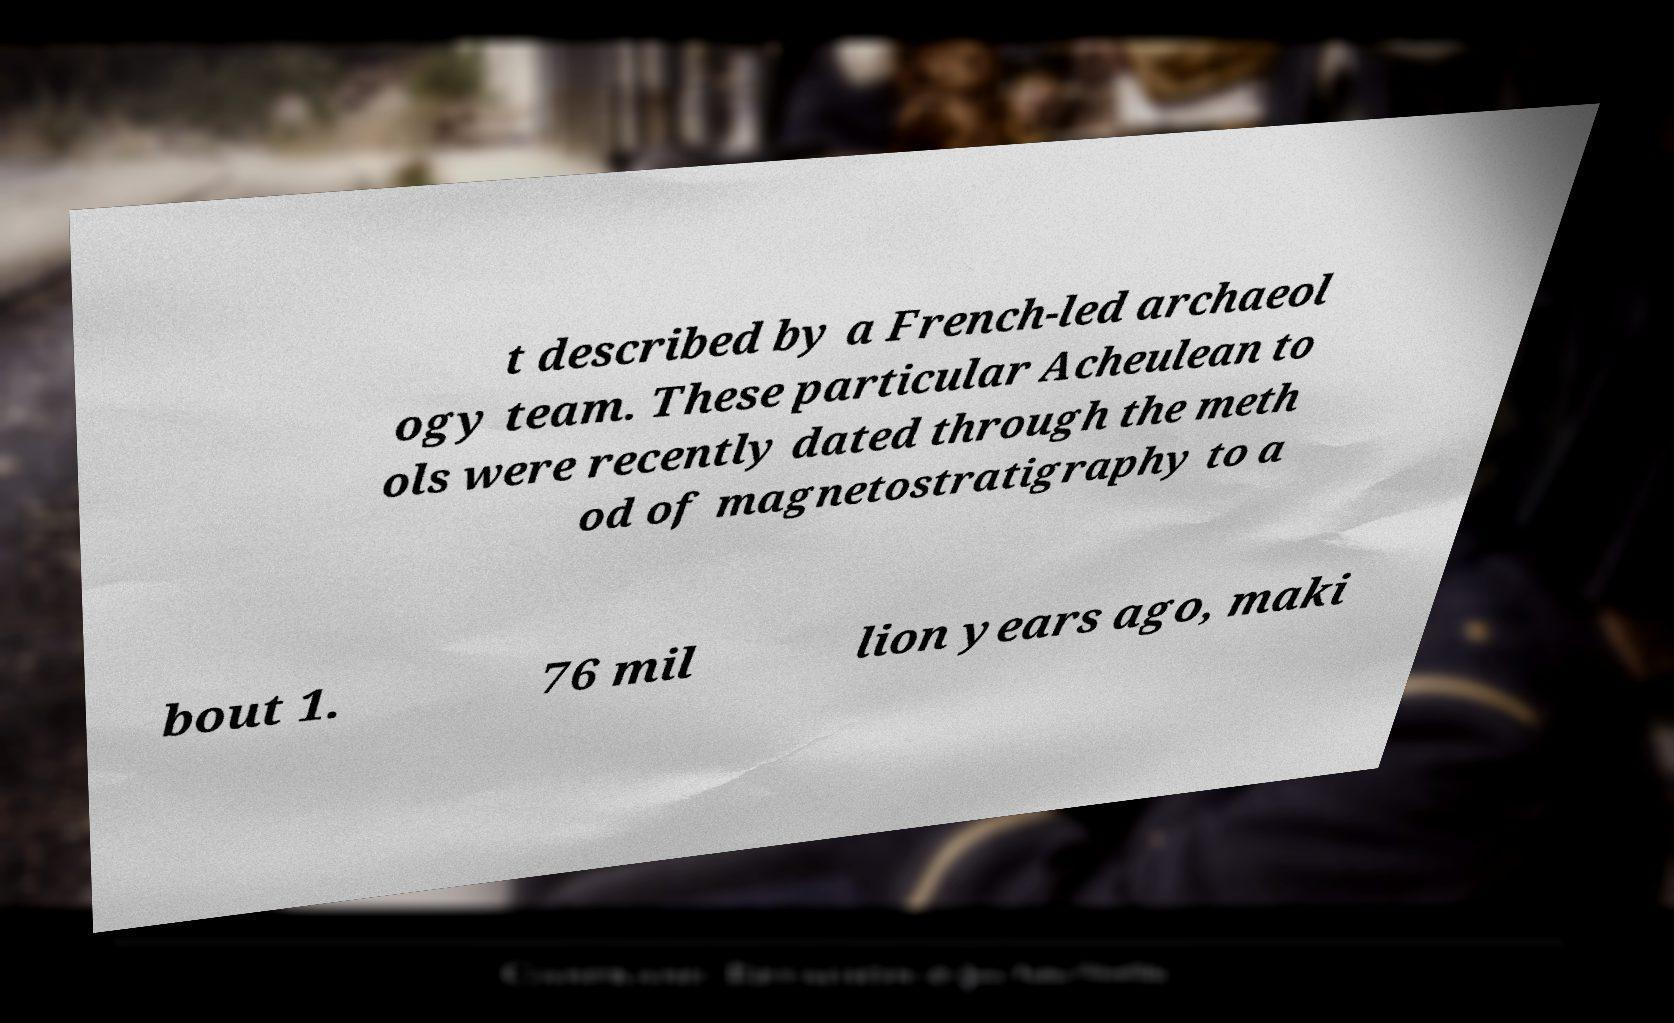Could you assist in decoding the text presented in this image and type it out clearly? t described by a French-led archaeol ogy team. These particular Acheulean to ols were recently dated through the meth od of magnetostratigraphy to a bout 1. 76 mil lion years ago, maki 